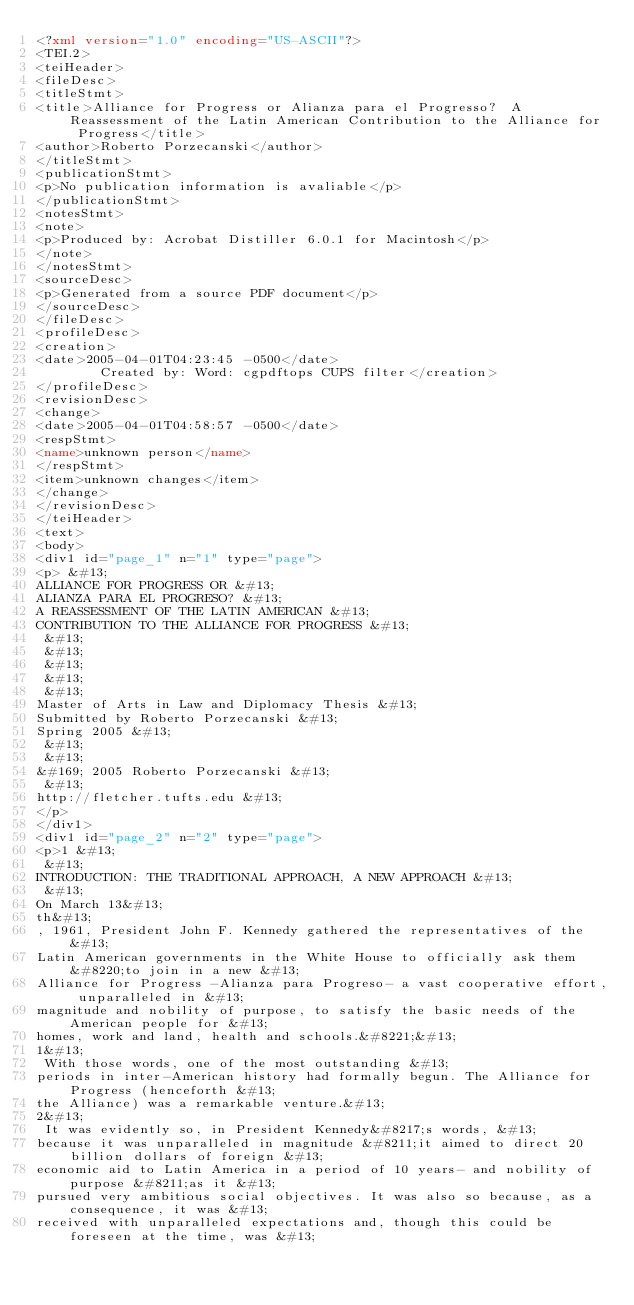Convert code to text. <code><loc_0><loc_0><loc_500><loc_500><_XML_><?xml version="1.0" encoding="US-ASCII"?>
<TEI.2>
<teiHeader>
<fileDesc>
<titleStmt>
<title>Alliance for Progress or Alianza para el Progresso?  A Reassessment of the Latin American Contribution to the Alliance for Progress</title>
<author>Roberto Porzecanski</author>
</titleStmt>
<publicationStmt>
<p>No publication information is avaliable</p>
</publicationStmt>
<notesStmt>
<note>
<p>Produced by: Acrobat Distiller 6.0.1 for Macintosh</p>
</note>
</notesStmt>
<sourceDesc>
<p>Generated from a source PDF document</p>
</sourceDesc>
</fileDesc>
<profileDesc>
<creation>
<date>2005-04-01T04:23:45 -0500</date>
	      Created by: Word: cgpdftops CUPS filter</creation>
</profileDesc>
<revisionDesc>
<change>
<date>2005-04-01T04:58:57 -0500</date>
<respStmt>
<name>unknown person</name>
</respStmt>
<item>unknown changes</item>
</change>
</revisionDesc>
</teiHeader>
<text>
<body>
<div1 id="page_1" n="1" type="page">
<p> &#13;
ALLIANCE FOR PROGRESS OR &#13;
ALIANZA PARA EL PROGRESO? &#13;
A REASSESSMENT OF THE LATIN AMERICAN &#13;
CONTRIBUTION TO THE ALLIANCE FOR PROGRESS &#13;
 &#13;
 &#13;
 &#13;
 &#13;
 &#13;
Master of Arts in Law and Diplomacy Thesis &#13;
Submitted by Roberto Porzecanski &#13;
Spring 2005 &#13;
 &#13;
 &#13;
&#169; 2005 Roberto Porzecanski &#13;
 &#13;
http://fletcher.tufts.edu &#13;
</p>
</div1>
<div1 id="page_2" n="2" type="page">
<p>1 &#13;
 &#13;
INTRODUCTION: THE TRADITIONAL APPROACH, A NEW APPROACH &#13;
 &#13;
On March 13&#13;
th&#13;
, 1961, President John F. Kennedy gathered the representatives of the &#13;
Latin American governments in the White House to officially ask them &#8220;to join in a new &#13;
Alliance for Progress -Alianza para Progreso- a vast cooperative effort, unparalleled in &#13;
magnitude and nobility of purpose, to satisfy the basic needs of the American people for &#13;
homes, work and land, health and schools.&#8221;&#13;
1&#13;
 With those words, one of the most outstanding &#13;
periods in inter-American history had formally begun. The Alliance for Progress (henceforth &#13;
the Alliance) was a remarkable venture.&#13;
2&#13;
 It was evidently so, in President Kennedy&#8217;s words, &#13;
because it was unparalleled in magnitude &#8211;it aimed to direct 20 billion dollars of foreign &#13;
economic aid to Latin America in a period of 10 years- and nobility of purpose &#8211;as it &#13;
pursued very ambitious social objectives. It was also so because, as a consequence, it was &#13;
received with unparalleled expectations and, though this could be foreseen at the time, was &#13;</code> 